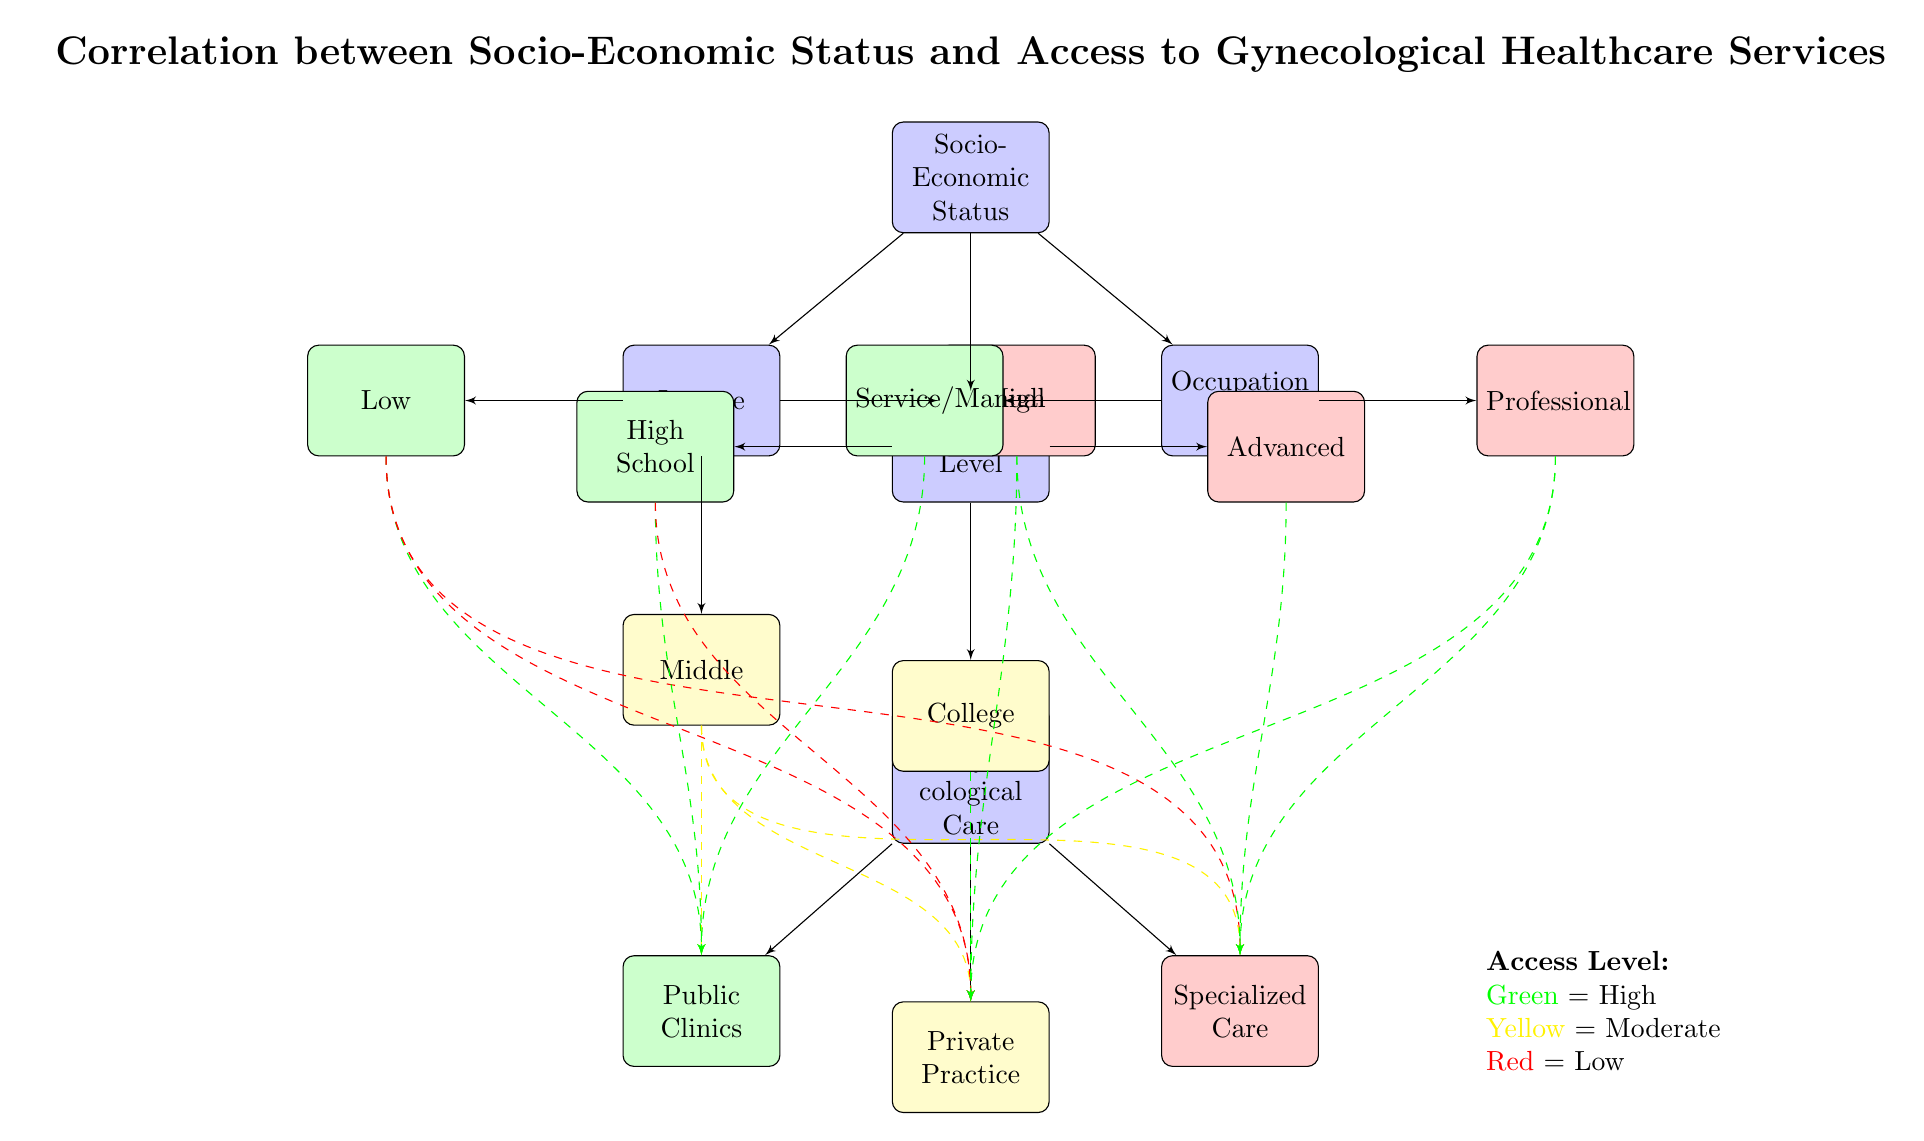What is the primary topic of the diagram? The title of the diagram is clearly stated at the top and indicates that the main subject is the correlation between socio-economic status and access to gynecological healthcare services.
Answer: Correlation between Socio-Economic Status and Access to Gynecological Healthcare Services Which node represents low socio-economic status? The leftmost block under "Socio-Economic Status" labeled "Income" contains the node "Low," indicating low socio-economic status.
Answer: Low How many levels of income are shown in the diagram? The node for "Income" branches into three levels: Low, Middle, and High, which gives a total of three distinct income levels represented in the diagram.
Answer: 3 Which access level is associated with high income? The block labeled "High" under the "Income" category connects to the access types "Private Practice" and "Specialized Care," which are indicated to have high access levels, as shown by the green dashed lines.
Answer: High What is the access level for individuals with a College education? The "College" block, under the "Education Level," connects to all care types but shows a moderate access level for "Public Clinics" and "Private Practice," indicated by yellow dashed lines, suggesting moderate access.
Answer: Moderate Which occupation type is linked to high access to gynecological care? The block labeled "Professional" under "Occupation Type" is associated with green dashed lines leading to both "Private Practice" and "Specialized Care," showing high access levels for individuals in this occupation category.
Answer: Professional Which type of care has low access for those with a Low income? The diagram illustrates that individuals with a "Low" income have dashed lines leading to all care types, although they primarily relate to the lower access level, highlighted by the red color around the care types. The lowest access is for "Public Clinics."
Answer: Public Clinics How does education level affect access to healthcare services? The diagram indicates a clear pattern where higher education levels (e.g., "Advanced" education) are connected to higher access levels (e.g., "Specialized Care"), while "High School" connects to lower levels, notably "Public Clinics," representing lower access.
Answer: Higher education leads to higher access What does the color coding in the diagram represent? The diagram uses a color-coding system where green indicates high access, yellow denotes moderate access, and red signifies low access levels, providing a quick visual understanding of access levels related to socio-economic factors.
Answer: Access levels: Green = High, Yellow = Moderate, Red = Low 